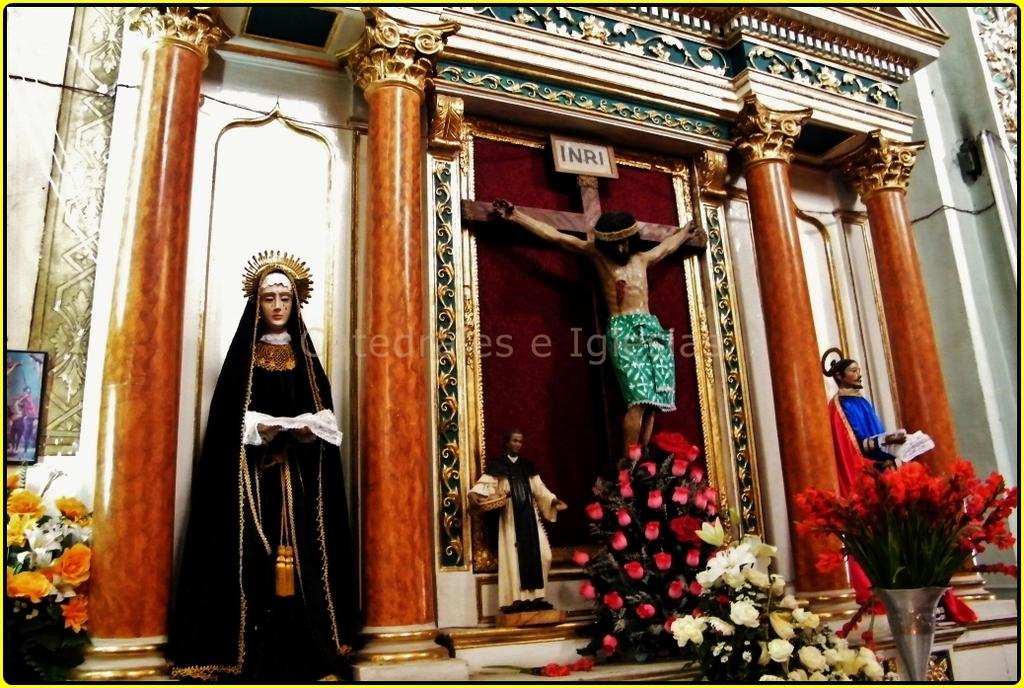What letters are at the top of the cross?
Provide a short and direct response. Inri. 